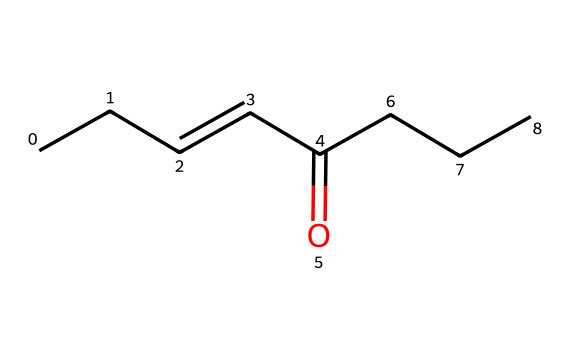how many carbon atoms are in this chemical? The SMILES representation shows "CCC=CC(=O)CCC," indicating the presence of five "C" symbols (each representing a carbon atom). Counting them gives a total of five carbon atoms.
Answer: five what is the functional group present in this structure? The structure contains the notation "C(=O)," which indicates the presence of a carbonyl group (C=O). This is characteristic of ketones or aldehydes. Since it's linked to carbon atoms on both sides, it suggests the presence of a ketone functional group.
Answer: ketone how many hydrogen atoms are in this compound? The carbon atoms in the structure can be determined to typically have two hydrogens each, but due to the presence of double bonds and functional groups modifying this standard count, the hydrogen number can be calculated. In total, there are 10 hydrogen atoms in this compound, after balancing the valencies of carbon and considering the carbonyl.
Answer: ten which bond type is indicated by the "=" in the SMILES? The "=" symbol in the SMILES denotes a double bond. Specifically, in this structure, it connects two carbon atoms and indicates that they share two pairs of electrons, which is a feature of unsaturation in organic compounds.
Answer: double bond what type of odor is typically associated with compounds containing this structure? Compounds like this often include esters and ketones, which can lead to fruity or sweet smells. In the case of rust and oxidation, it might carry a metallic or iron-like smell. Such odors are typically described as pungent.
Answer: pungent is this compound typically found in rusty environments? Iron oxide compounds often develop a range of volatile compounds during oxidation. This specific compound, being an oxidation product or derivative thereof, indicates that it may correspond to the odors we associate with rust.
Answer: yes 